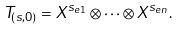Convert formula to latex. <formula><loc_0><loc_0><loc_500><loc_500>T _ { ( s , 0 ) } = X ^ { s _ { e 1 } } \otimes \cdots \otimes X ^ { s _ { e n } } .</formula> 